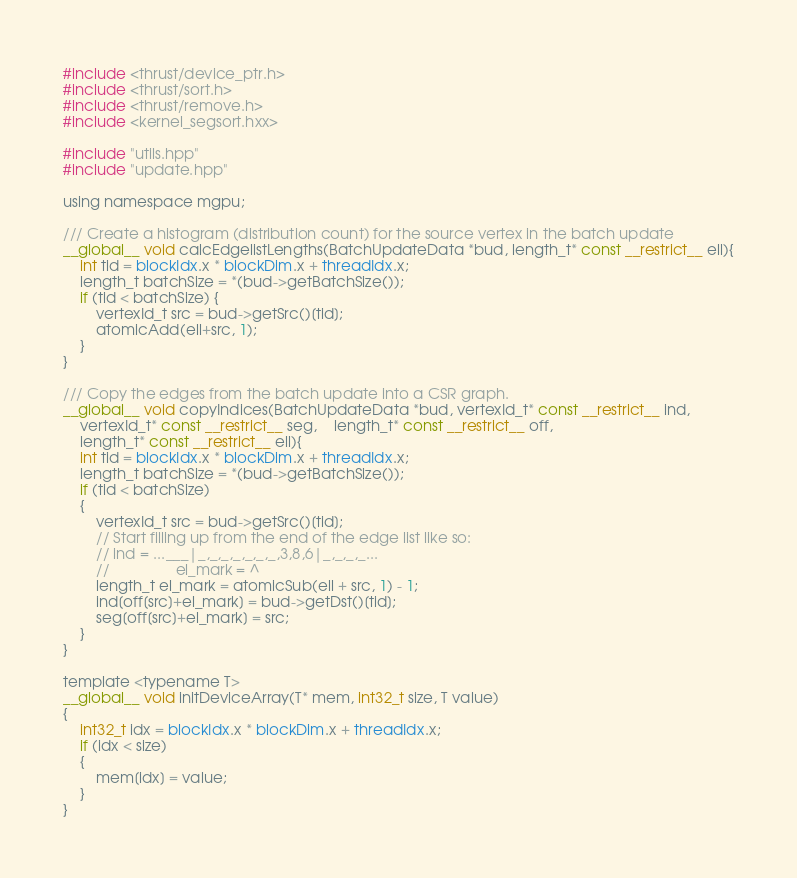<code> <loc_0><loc_0><loc_500><loc_500><_Cuda_>#include <thrust/device_ptr.h>
#include <thrust/sort.h>
#include <thrust/remove.h>
#include <kernel_segsort.hxx>

#include "utils.hpp"
#include "update.hpp"

using namespace mgpu;

/// Create a histogram (distribution count) for the source vertex in the batch update
__global__ void calcEdgelistLengths(BatchUpdateData *bud, length_t* const __restrict__ ell){
	int tid = blockIdx.x * blockDim.x + threadIdx.x;
	length_t batchSize = *(bud->getBatchSize());
	if (tid < batchSize) {
		vertexId_t src = bud->getSrc()[tid];
		atomicAdd(ell+src, 1);
	}
}

/// Copy the edges from the batch update into a CSR graph.
__global__ void copyIndices(BatchUpdateData *bud, vertexId_t* const __restrict__ ind,
	vertexId_t* const __restrict__ seg,	length_t* const __restrict__ off,
	length_t* const __restrict__ ell){
	int tid = blockIdx.x * blockDim.x + threadIdx.x;
	length_t batchSize = *(bud->getBatchSize());
	if (tid < batchSize)
	{
		vertexId_t src = bud->getSrc()[tid];
		// Start filling up from the end of the edge list like so:
		// ind = ...___|_,_,_,_,_,_,_,3,8,6|_,_,_,_...
		//                el_mark = ^
		length_t el_mark = atomicSub(ell + src, 1) - 1;
		ind[off[src]+el_mark] = bud->getDst()[tid];
		seg[off[src]+el_mark] = src;
	}
}

template <typename T>
__global__ void initDeviceArray(T* mem, int32_t size, T value)
{
	int32_t idx = blockIdx.x * blockDim.x + threadIdx.x;
	if (idx < size)
	{
		mem[idx] = value;
	}
}

</code> 